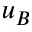Convert formula to latex. <formula><loc_0><loc_0><loc_500><loc_500>u _ { B }</formula> 